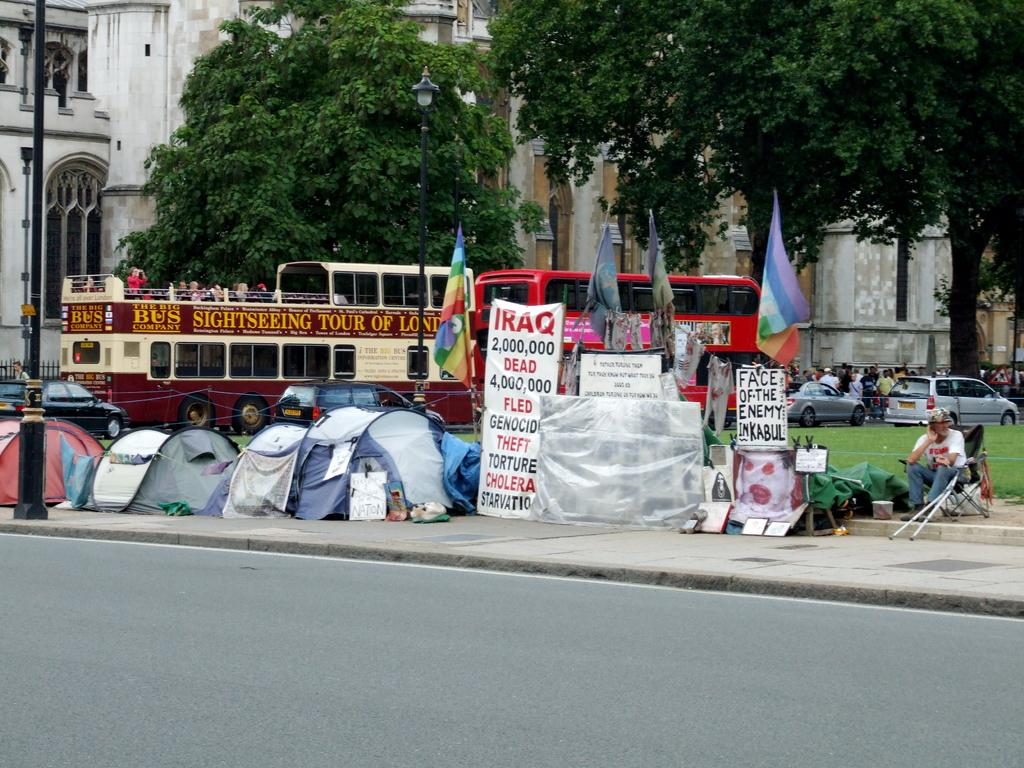What type of structure is visible in the image? There is a building in the image. What can be seen in the background of the image? There are trees in the image. What else is present in the image besides the building and trees? There are vehicles in the image. Can you see a kitty playing with a body near the moon in the image? There is no kitty, body, or moon present in the image. 